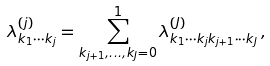<formula> <loc_0><loc_0><loc_500><loc_500>\lambda _ { k _ { 1 } \cdots k _ { j } } ^ { ( j ) } = \sum _ { k _ { j + 1 } , \dots , k _ { J } = 0 } ^ { 1 } \lambda _ { k _ { 1 } \cdots k _ { j } k _ { j + 1 } \cdots k _ { J } } ^ { ( J ) } \, ,</formula> 